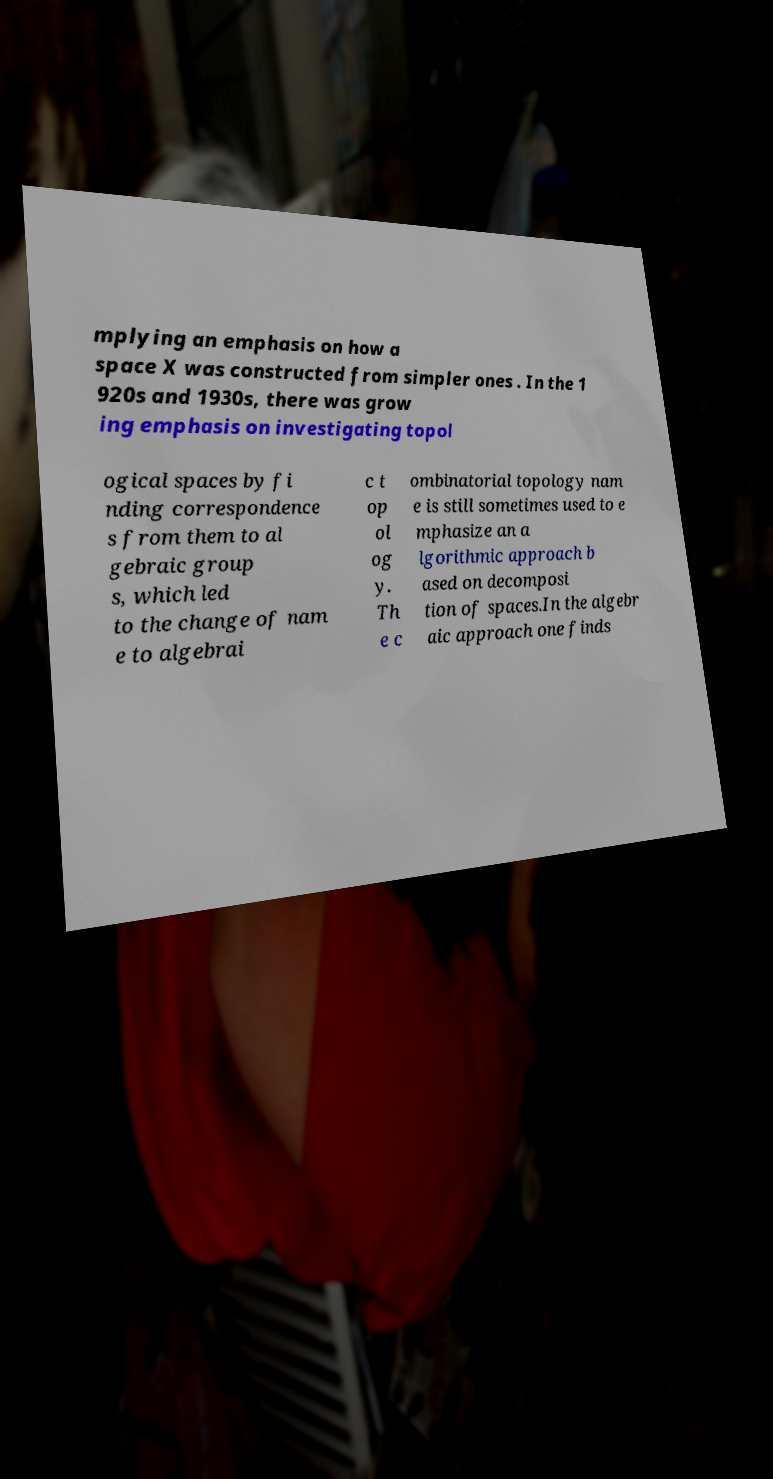Could you assist in decoding the text presented in this image and type it out clearly? mplying an emphasis on how a space X was constructed from simpler ones . In the 1 920s and 1930s, there was grow ing emphasis on investigating topol ogical spaces by fi nding correspondence s from them to al gebraic group s, which led to the change of nam e to algebrai c t op ol og y. Th e c ombinatorial topology nam e is still sometimes used to e mphasize an a lgorithmic approach b ased on decomposi tion of spaces.In the algebr aic approach one finds 